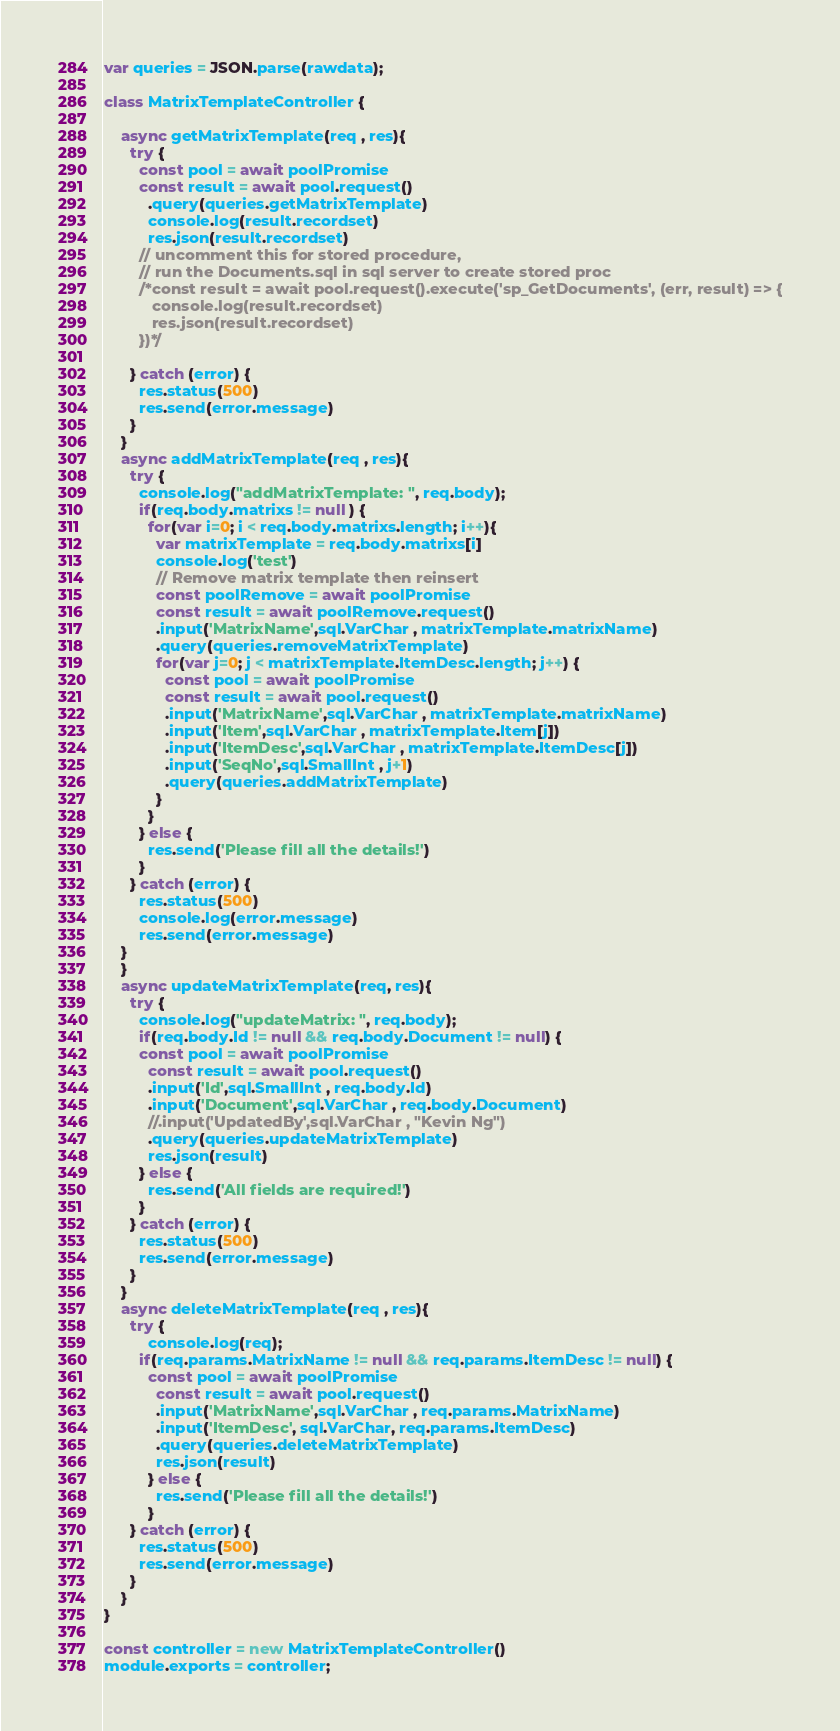Convert code to text. <code><loc_0><loc_0><loc_500><loc_500><_JavaScript_>var queries = JSON.parse(rawdata);

class MatrixTemplateController {

    async getMatrixTemplate(req , res){
      try {
        const pool = await poolPromise
        const result = await pool.request()
          .query(queries.getMatrixTemplate)
          console.log(result.recordset)
          res.json(result.recordset)
        // uncomment this for stored procedure,
        // run the Documents.sql in sql server to create stored proc
        /*const result = await pool.request().execute('sp_GetDocuments', (err, result) => {
           console.log(result.recordset)
           res.json(result.recordset)
        })*/

      } catch (error) {
        res.status(500)
        res.send(error.message)
      }
    }
    async addMatrixTemplate(req , res){
      try {
        console.log("addMatrixTemplate: ", req.body);
        if(req.body.matrixs != null ) {
          for(var i=0; i < req.body.matrixs.length; i++){
            var matrixTemplate = req.body.matrixs[i]
            console.log('test')
            // Remove matrix template then reinsert
            const poolRemove = await poolPromise
            const result = await poolRemove.request()
            .input('MatrixName',sql.VarChar , matrixTemplate.matrixName)
            .query(queries.removeMatrixTemplate)
            for(var j=0; j < matrixTemplate.ItemDesc.length; j++) {
              const pool = await poolPromise
              const result = await pool.request()
              .input('MatrixName',sql.VarChar , matrixTemplate.matrixName)
              .input('Item',sql.VarChar , matrixTemplate.Item[j])
              .input('ItemDesc',sql.VarChar , matrixTemplate.ItemDesc[j])
              .input('SeqNo',sql.SmallInt , j+1)
              .query(queries.addMatrixTemplate)
            }
          }
        } else {
          res.send('Please fill all the details!')
        }
      } catch (error) {
        res.status(500)
        console.log(error.message)
        res.send(error.message)
    }
    }
    async updateMatrixTemplate(req, res){
      try {
        console.log("updateMatrix: ", req.body);
        if(req.body.Id != null && req.body.Document != null) {
        const pool = await poolPromise
          const result = await pool.request()
          .input('Id',sql.SmallInt , req.body.Id)
          .input('Document',sql.VarChar , req.body.Document)
          //.input('UpdatedBy',sql.VarChar , "Kevin Ng")
          .query(queries.updateMatrixTemplate)
          res.json(result)
        } else {
          res.send('All fields are required!')
        }
      } catch (error) {
        res.status(500)
        res.send(error.message)
      }
    }
    async deleteMatrixTemplate(req , res){
      try {
          console.log(req);
        if(req.params.MatrixName != null && req.params.ItemDesc != null) {
          const pool = await poolPromise
            const result = await pool.request()
            .input('MatrixName',sql.VarChar , req.params.MatrixName)
            .input('ItemDesc', sql.VarChar, req.params.ItemDesc)
            .query(queries.deleteMatrixTemplate)
            res.json(result)
          } else {
            res.send('Please fill all the details!')
          }
      } catch (error) {
        res.status(500)
        res.send(error.message)
      }
    }
}

const controller = new MatrixTemplateController()
module.exports = controller;</code> 